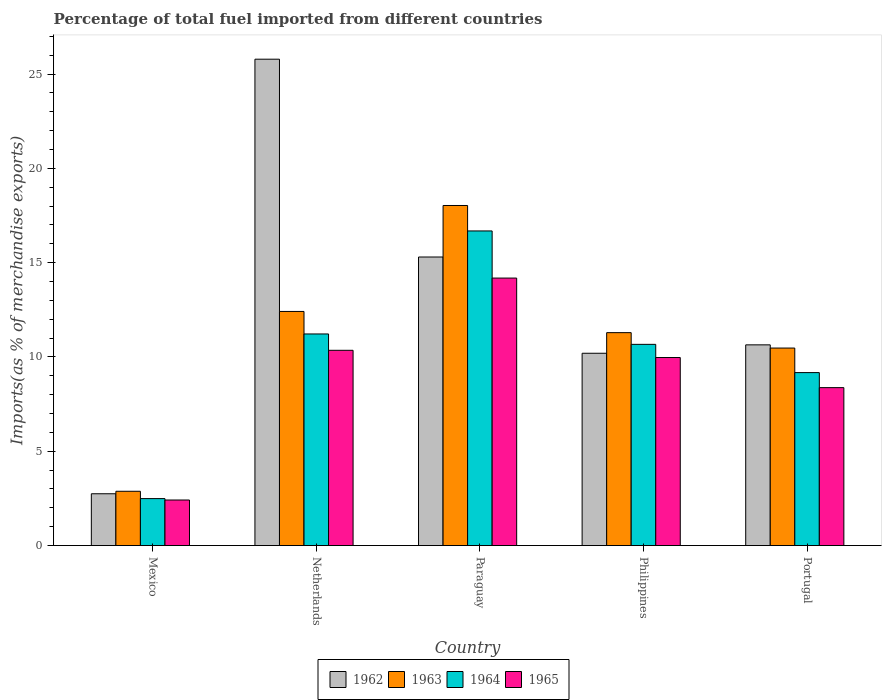Are the number of bars on each tick of the X-axis equal?
Your answer should be compact. Yes. How many bars are there on the 1st tick from the right?
Provide a short and direct response. 4. In how many cases, is the number of bars for a given country not equal to the number of legend labels?
Keep it short and to the point. 0. What is the percentage of imports to different countries in 1964 in Philippines?
Provide a short and direct response. 10.67. Across all countries, what is the maximum percentage of imports to different countries in 1962?
Your answer should be very brief. 25.79. Across all countries, what is the minimum percentage of imports to different countries in 1963?
Your answer should be compact. 2.88. In which country was the percentage of imports to different countries in 1963 maximum?
Your answer should be very brief. Paraguay. What is the total percentage of imports to different countries in 1962 in the graph?
Give a very brief answer. 64.67. What is the difference between the percentage of imports to different countries in 1962 in Netherlands and that in Philippines?
Give a very brief answer. 15.59. What is the difference between the percentage of imports to different countries in 1964 in Netherlands and the percentage of imports to different countries in 1965 in Mexico?
Offer a terse response. 8.8. What is the average percentage of imports to different countries in 1965 per country?
Your answer should be compact. 9.06. What is the difference between the percentage of imports to different countries of/in 1965 and percentage of imports to different countries of/in 1962 in Paraguay?
Give a very brief answer. -1.12. What is the ratio of the percentage of imports to different countries in 1963 in Mexico to that in Paraguay?
Your response must be concise. 0.16. Is the percentage of imports to different countries in 1965 in Philippines less than that in Portugal?
Provide a short and direct response. No. What is the difference between the highest and the second highest percentage of imports to different countries in 1965?
Provide a short and direct response. -0.38. What is the difference between the highest and the lowest percentage of imports to different countries in 1963?
Provide a short and direct response. 15.15. In how many countries, is the percentage of imports to different countries in 1963 greater than the average percentage of imports to different countries in 1963 taken over all countries?
Keep it short and to the point. 3. Is it the case that in every country, the sum of the percentage of imports to different countries in 1963 and percentage of imports to different countries in 1965 is greater than the sum of percentage of imports to different countries in 1962 and percentage of imports to different countries in 1964?
Your answer should be compact. No. What does the 3rd bar from the left in Netherlands represents?
Make the answer very short. 1964. What is the difference between two consecutive major ticks on the Y-axis?
Your answer should be compact. 5. Does the graph contain any zero values?
Provide a short and direct response. No. Does the graph contain grids?
Offer a terse response. No. How are the legend labels stacked?
Offer a very short reply. Horizontal. What is the title of the graph?
Your response must be concise. Percentage of total fuel imported from different countries. Does "2002" appear as one of the legend labels in the graph?
Offer a very short reply. No. What is the label or title of the X-axis?
Make the answer very short. Country. What is the label or title of the Y-axis?
Offer a very short reply. Imports(as % of merchandise exports). What is the Imports(as % of merchandise exports) of 1962 in Mexico?
Your answer should be compact. 2.75. What is the Imports(as % of merchandise exports) of 1963 in Mexico?
Offer a very short reply. 2.88. What is the Imports(as % of merchandise exports) of 1964 in Mexico?
Offer a terse response. 2.49. What is the Imports(as % of merchandise exports) of 1965 in Mexico?
Provide a short and direct response. 2.42. What is the Imports(as % of merchandise exports) of 1962 in Netherlands?
Give a very brief answer. 25.79. What is the Imports(as % of merchandise exports) of 1963 in Netherlands?
Ensure brevity in your answer.  12.41. What is the Imports(as % of merchandise exports) in 1964 in Netherlands?
Keep it short and to the point. 11.22. What is the Imports(as % of merchandise exports) in 1965 in Netherlands?
Keep it short and to the point. 10.35. What is the Imports(as % of merchandise exports) in 1962 in Paraguay?
Offer a very short reply. 15.3. What is the Imports(as % of merchandise exports) of 1963 in Paraguay?
Give a very brief answer. 18.03. What is the Imports(as % of merchandise exports) in 1964 in Paraguay?
Offer a very short reply. 16.68. What is the Imports(as % of merchandise exports) in 1965 in Paraguay?
Your answer should be very brief. 14.18. What is the Imports(as % of merchandise exports) in 1962 in Philippines?
Keep it short and to the point. 10.2. What is the Imports(as % of merchandise exports) in 1963 in Philippines?
Make the answer very short. 11.29. What is the Imports(as % of merchandise exports) in 1964 in Philippines?
Make the answer very short. 10.67. What is the Imports(as % of merchandise exports) in 1965 in Philippines?
Make the answer very short. 9.97. What is the Imports(as % of merchandise exports) of 1962 in Portugal?
Provide a short and direct response. 10.64. What is the Imports(as % of merchandise exports) in 1963 in Portugal?
Your answer should be compact. 10.47. What is the Imports(as % of merchandise exports) of 1964 in Portugal?
Give a very brief answer. 9.17. What is the Imports(as % of merchandise exports) in 1965 in Portugal?
Your answer should be compact. 8.37. Across all countries, what is the maximum Imports(as % of merchandise exports) of 1962?
Keep it short and to the point. 25.79. Across all countries, what is the maximum Imports(as % of merchandise exports) in 1963?
Offer a very short reply. 18.03. Across all countries, what is the maximum Imports(as % of merchandise exports) of 1964?
Keep it short and to the point. 16.68. Across all countries, what is the maximum Imports(as % of merchandise exports) in 1965?
Offer a very short reply. 14.18. Across all countries, what is the minimum Imports(as % of merchandise exports) of 1962?
Make the answer very short. 2.75. Across all countries, what is the minimum Imports(as % of merchandise exports) of 1963?
Offer a very short reply. 2.88. Across all countries, what is the minimum Imports(as % of merchandise exports) in 1964?
Your answer should be very brief. 2.49. Across all countries, what is the minimum Imports(as % of merchandise exports) in 1965?
Provide a short and direct response. 2.42. What is the total Imports(as % of merchandise exports) in 1962 in the graph?
Your answer should be very brief. 64.67. What is the total Imports(as % of merchandise exports) in 1963 in the graph?
Make the answer very short. 55.08. What is the total Imports(as % of merchandise exports) in 1964 in the graph?
Keep it short and to the point. 50.23. What is the total Imports(as % of merchandise exports) in 1965 in the graph?
Give a very brief answer. 45.29. What is the difference between the Imports(as % of merchandise exports) of 1962 in Mexico and that in Netherlands?
Ensure brevity in your answer.  -23.04. What is the difference between the Imports(as % of merchandise exports) in 1963 in Mexico and that in Netherlands?
Ensure brevity in your answer.  -9.53. What is the difference between the Imports(as % of merchandise exports) of 1964 in Mexico and that in Netherlands?
Ensure brevity in your answer.  -8.73. What is the difference between the Imports(as % of merchandise exports) of 1965 in Mexico and that in Netherlands?
Provide a short and direct response. -7.94. What is the difference between the Imports(as % of merchandise exports) of 1962 in Mexico and that in Paraguay?
Your response must be concise. -12.55. What is the difference between the Imports(as % of merchandise exports) in 1963 in Mexico and that in Paraguay?
Offer a very short reply. -15.15. What is the difference between the Imports(as % of merchandise exports) in 1964 in Mexico and that in Paraguay?
Your answer should be very brief. -14.19. What is the difference between the Imports(as % of merchandise exports) of 1965 in Mexico and that in Paraguay?
Your answer should be compact. -11.77. What is the difference between the Imports(as % of merchandise exports) in 1962 in Mexico and that in Philippines?
Your answer should be very brief. -7.45. What is the difference between the Imports(as % of merchandise exports) in 1963 in Mexico and that in Philippines?
Your answer should be very brief. -8.41. What is the difference between the Imports(as % of merchandise exports) of 1964 in Mexico and that in Philippines?
Your answer should be compact. -8.18. What is the difference between the Imports(as % of merchandise exports) in 1965 in Mexico and that in Philippines?
Keep it short and to the point. -7.55. What is the difference between the Imports(as % of merchandise exports) of 1962 in Mexico and that in Portugal?
Your answer should be compact. -7.89. What is the difference between the Imports(as % of merchandise exports) in 1963 in Mexico and that in Portugal?
Offer a terse response. -7.59. What is the difference between the Imports(as % of merchandise exports) of 1964 in Mexico and that in Portugal?
Keep it short and to the point. -6.68. What is the difference between the Imports(as % of merchandise exports) in 1965 in Mexico and that in Portugal?
Ensure brevity in your answer.  -5.96. What is the difference between the Imports(as % of merchandise exports) in 1962 in Netherlands and that in Paraguay?
Make the answer very short. 10.49. What is the difference between the Imports(as % of merchandise exports) of 1963 in Netherlands and that in Paraguay?
Your answer should be compact. -5.62. What is the difference between the Imports(as % of merchandise exports) of 1964 in Netherlands and that in Paraguay?
Make the answer very short. -5.46. What is the difference between the Imports(as % of merchandise exports) of 1965 in Netherlands and that in Paraguay?
Offer a terse response. -3.83. What is the difference between the Imports(as % of merchandise exports) of 1962 in Netherlands and that in Philippines?
Keep it short and to the point. 15.59. What is the difference between the Imports(as % of merchandise exports) in 1963 in Netherlands and that in Philippines?
Ensure brevity in your answer.  1.12. What is the difference between the Imports(as % of merchandise exports) of 1964 in Netherlands and that in Philippines?
Offer a terse response. 0.55. What is the difference between the Imports(as % of merchandise exports) in 1965 in Netherlands and that in Philippines?
Make the answer very short. 0.38. What is the difference between the Imports(as % of merchandise exports) of 1962 in Netherlands and that in Portugal?
Give a very brief answer. 15.15. What is the difference between the Imports(as % of merchandise exports) in 1963 in Netherlands and that in Portugal?
Provide a succinct answer. 1.94. What is the difference between the Imports(as % of merchandise exports) of 1964 in Netherlands and that in Portugal?
Make the answer very short. 2.05. What is the difference between the Imports(as % of merchandise exports) in 1965 in Netherlands and that in Portugal?
Keep it short and to the point. 1.98. What is the difference between the Imports(as % of merchandise exports) of 1962 in Paraguay and that in Philippines?
Offer a terse response. 5.1. What is the difference between the Imports(as % of merchandise exports) in 1963 in Paraguay and that in Philippines?
Keep it short and to the point. 6.74. What is the difference between the Imports(as % of merchandise exports) of 1964 in Paraguay and that in Philippines?
Your answer should be very brief. 6.01. What is the difference between the Imports(as % of merchandise exports) in 1965 in Paraguay and that in Philippines?
Your answer should be compact. 4.21. What is the difference between the Imports(as % of merchandise exports) in 1962 in Paraguay and that in Portugal?
Provide a short and direct response. 4.66. What is the difference between the Imports(as % of merchandise exports) in 1963 in Paraguay and that in Portugal?
Provide a succinct answer. 7.56. What is the difference between the Imports(as % of merchandise exports) in 1964 in Paraguay and that in Portugal?
Offer a very short reply. 7.51. What is the difference between the Imports(as % of merchandise exports) in 1965 in Paraguay and that in Portugal?
Your answer should be very brief. 5.81. What is the difference between the Imports(as % of merchandise exports) of 1962 in Philippines and that in Portugal?
Offer a very short reply. -0.45. What is the difference between the Imports(as % of merchandise exports) in 1963 in Philippines and that in Portugal?
Ensure brevity in your answer.  0.82. What is the difference between the Imports(as % of merchandise exports) in 1964 in Philippines and that in Portugal?
Keep it short and to the point. 1.5. What is the difference between the Imports(as % of merchandise exports) of 1965 in Philippines and that in Portugal?
Keep it short and to the point. 1.6. What is the difference between the Imports(as % of merchandise exports) of 1962 in Mexico and the Imports(as % of merchandise exports) of 1963 in Netherlands?
Ensure brevity in your answer.  -9.67. What is the difference between the Imports(as % of merchandise exports) in 1962 in Mexico and the Imports(as % of merchandise exports) in 1964 in Netherlands?
Offer a terse response. -8.47. What is the difference between the Imports(as % of merchandise exports) of 1962 in Mexico and the Imports(as % of merchandise exports) of 1965 in Netherlands?
Offer a terse response. -7.61. What is the difference between the Imports(as % of merchandise exports) in 1963 in Mexico and the Imports(as % of merchandise exports) in 1964 in Netherlands?
Give a very brief answer. -8.34. What is the difference between the Imports(as % of merchandise exports) of 1963 in Mexico and the Imports(as % of merchandise exports) of 1965 in Netherlands?
Keep it short and to the point. -7.47. What is the difference between the Imports(as % of merchandise exports) of 1964 in Mexico and the Imports(as % of merchandise exports) of 1965 in Netherlands?
Provide a short and direct response. -7.86. What is the difference between the Imports(as % of merchandise exports) in 1962 in Mexico and the Imports(as % of merchandise exports) in 1963 in Paraguay?
Keep it short and to the point. -15.28. What is the difference between the Imports(as % of merchandise exports) of 1962 in Mexico and the Imports(as % of merchandise exports) of 1964 in Paraguay?
Provide a short and direct response. -13.93. What is the difference between the Imports(as % of merchandise exports) of 1962 in Mexico and the Imports(as % of merchandise exports) of 1965 in Paraguay?
Your answer should be very brief. -11.44. What is the difference between the Imports(as % of merchandise exports) of 1963 in Mexico and the Imports(as % of merchandise exports) of 1964 in Paraguay?
Your response must be concise. -13.8. What is the difference between the Imports(as % of merchandise exports) in 1963 in Mexico and the Imports(as % of merchandise exports) in 1965 in Paraguay?
Keep it short and to the point. -11.3. What is the difference between the Imports(as % of merchandise exports) in 1964 in Mexico and the Imports(as % of merchandise exports) in 1965 in Paraguay?
Ensure brevity in your answer.  -11.69. What is the difference between the Imports(as % of merchandise exports) in 1962 in Mexico and the Imports(as % of merchandise exports) in 1963 in Philippines?
Provide a succinct answer. -8.54. What is the difference between the Imports(as % of merchandise exports) of 1962 in Mexico and the Imports(as % of merchandise exports) of 1964 in Philippines?
Offer a very short reply. -7.92. What is the difference between the Imports(as % of merchandise exports) of 1962 in Mexico and the Imports(as % of merchandise exports) of 1965 in Philippines?
Your answer should be compact. -7.22. What is the difference between the Imports(as % of merchandise exports) in 1963 in Mexico and the Imports(as % of merchandise exports) in 1964 in Philippines?
Offer a terse response. -7.79. What is the difference between the Imports(as % of merchandise exports) of 1963 in Mexico and the Imports(as % of merchandise exports) of 1965 in Philippines?
Your answer should be compact. -7.09. What is the difference between the Imports(as % of merchandise exports) in 1964 in Mexico and the Imports(as % of merchandise exports) in 1965 in Philippines?
Your response must be concise. -7.48. What is the difference between the Imports(as % of merchandise exports) in 1962 in Mexico and the Imports(as % of merchandise exports) in 1963 in Portugal?
Offer a very short reply. -7.73. What is the difference between the Imports(as % of merchandise exports) in 1962 in Mexico and the Imports(as % of merchandise exports) in 1964 in Portugal?
Keep it short and to the point. -6.42. What is the difference between the Imports(as % of merchandise exports) of 1962 in Mexico and the Imports(as % of merchandise exports) of 1965 in Portugal?
Offer a very short reply. -5.63. What is the difference between the Imports(as % of merchandise exports) of 1963 in Mexico and the Imports(as % of merchandise exports) of 1964 in Portugal?
Offer a terse response. -6.29. What is the difference between the Imports(as % of merchandise exports) of 1963 in Mexico and the Imports(as % of merchandise exports) of 1965 in Portugal?
Your response must be concise. -5.49. What is the difference between the Imports(as % of merchandise exports) in 1964 in Mexico and the Imports(as % of merchandise exports) in 1965 in Portugal?
Ensure brevity in your answer.  -5.88. What is the difference between the Imports(as % of merchandise exports) in 1962 in Netherlands and the Imports(as % of merchandise exports) in 1963 in Paraguay?
Your answer should be compact. 7.76. What is the difference between the Imports(as % of merchandise exports) of 1962 in Netherlands and the Imports(as % of merchandise exports) of 1964 in Paraguay?
Your response must be concise. 9.11. What is the difference between the Imports(as % of merchandise exports) in 1962 in Netherlands and the Imports(as % of merchandise exports) in 1965 in Paraguay?
Your answer should be very brief. 11.6. What is the difference between the Imports(as % of merchandise exports) in 1963 in Netherlands and the Imports(as % of merchandise exports) in 1964 in Paraguay?
Make the answer very short. -4.27. What is the difference between the Imports(as % of merchandise exports) of 1963 in Netherlands and the Imports(as % of merchandise exports) of 1965 in Paraguay?
Provide a short and direct response. -1.77. What is the difference between the Imports(as % of merchandise exports) of 1964 in Netherlands and the Imports(as % of merchandise exports) of 1965 in Paraguay?
Offer a terse response. -2.96. What is the difference between the Imports(as % of merchandise exports) in 1962 in Netherlands and the Imports(as % of merchandise exports) in 1963 in Philippines?
Offer a terse response. 14.5. What is the difference between the Imports(as % of merchandise exports) in 1962 in Netherlands and the Imports(as % of merchandise exports) in 1964 in Philippines?
Ensure brevity in your answer.  15.12. What is the difference between the Imports(as % of merchandise exports) of 1962 in Netherlands and the Imports(as % of merchandise exports) of 1965 in Philippines?
Offer a very short reply. 15.82. What is the difference between the Imports(as % of merchandise exports) of 1963 in Netherlands and the Imports(as % of merchandise exports) of 1964 in Philippines?
Provide a succinct answer. 1.74. What is the difference between the Imports(as % of merchandise exports) in 1963 in Netherlands and the Imports(as % of merchandise exports) in 1965 in Philippines?
Keep it short and to the point. 2.44. What is the difference between the Imports(as % of merchandise exports) of 1964 in Netherlands and the Imports(as % of merchandise exports) of 1965 in Philippines?
Make the answer very short. 1.25. What is the difference between the Imports(as % of merchandise exports) in 1962 in Netherlands and the Imports(as % of merchandise exports) in 1963 in Portugal?
Your answer should be compact. 15.32. What is the difference between the Imports(as % of merchandise exports) of 1962 in Netherlands and the Imports(as % of merchandise exports) of 1964 in Portugal?
Your answer should be compact. 16.62. What is the difference between the Imports(as % of merchandise exports) in 1962 in Netherlands and the Imports(as % of merchandise exports) in 1965 in Portugal?
Your response must be concise. 17.41. What is the difference between the Imports(as % of merchandise exports) of 1963 in Netherlands and the Imports(as % of merchandise exports) of 1964 in Portugal?
Provide a succinct answer. 3.24. What is the difference between the Imports(as % of merchandise exports) in 1963 in Netherlands and the Imports(as % of merchandise exports) in 1965 in Portugal?
Give a very brief answer. 4.04. What is the difference between the Imports(as % of merchandise exports) in 1964 in Netherlands and the Imports(as % of merchandise exports) in 1965 in Portugal?
Your answer should be compact. 2.85. What is the difference between the Imports(as % of merchandise exports) of 1962 in Paraguay and the Imports(as % of merchandise exports) of 1963 in Philippines?
Your answer should be very brief. 4.01. What is the difference between the Imports(as % of merchandise exports) of 1962 in Paraguay and the Imports(as % of merchandise exports) of 1964 in Philippines?
Keep it short and to the point. 4.63. What is the difference between the Imports(as % of merchandise exports) in 1962 in Paraguay and the Imports(as % of merchandise exports) in 1965 in Philippines?
Offer a very short reply. 5.33. What is the difference between the Imports(as % of merchandise exports) in 1963 in Paraguay and the Imports(as % of merchandise exports) in 1964 in Philippines?
Your answer should be very brief. 7.36. What is the difference between the Imports(as % of merchandise exports) of 1963 in Paraguay and the Imports(as % of merchandise exports) of 1965 in Philippines?
Provide a succinct answer. 8.06. What is the difference between the Imports(as % of merchandise exports) of 1964 in Paraguay and the Imports(as % of merchandise exports) of 1965 in Philippines?
Offer a terse response. 6.71. What is the difference between the Imports(as % of merchandise exports) of 1962 in Paraguay and the Imports(as % of merchandise exports) of 1963 in Portugal?
Offer a very short reply. 4.83. What is the difference between the Imports(as % of merchandise exports) in 1962 in Paraguay and the Imports(as % of merchandise exports) in 1964 in Portugal?
Ensure brevity in your answer.  6.13. What is the difference between the Imports(as % of merchandise exports) in 1962 in Paraguay and the Imports(as % of merchandise exports) in 1965 in Portugal?
Your answer should be compact. 6.93. What is the difference between the Imports(as % of merchandise exports) in 1963 in Paraguay and the Imports(as % of merchandise exports) in 1964 in Portugal?
Offer a very short reply. 8.86. What is the difference between the Imports(as % of merchandise exports) of 1963 in Paraguay and the Imports(as % of merchandise exports) of 1965 in Portugal?
Provide a short and direct response. 9.66. What is the difference between the Imports(as % of merchandise exports) in 1964 in Paraguay and the Imports(as % of merchandise exports) in 1965 in Portugal?
Provide a short and direct response. 8.31. What is the difference between the Imports(as % of merchandise exports) of 1962 in Philippines and the Imports(as % of merchandise exports) of 1963 in Portugal?
Offer a very short reply. -0.28. What is the difference between the Imports(as % of merchandise exports) in 1962 in Philippines and the Imports(as % of merchandise exports) in 1964 in Portugal?
Your answer should be compact. 1.03. What is the difference between the Imports(as % of merchandise exports) of 1962 in Philippines and the Imports(as % of merchandise exports) of 1965 in Portugal?
Your answer should be compact. 1.82. What is the difference between the Imports(as % of merchandise exports) in 1963 in Philippines and the Imports(as % of merchandise exports) in 1964 in Portugal?
Ensure brevity in your answer.  2.12. What is the difference between the Imports(as % of merchandise exports) in 1963 in Philippines and the Imports(as % of merchandise exports) in 1965 in Portugal?
Make the answer very short. 2.92. What is the difference between the Imports(as % of merchandise exports) of 1964 in Philippines and the Imports(as % of merchandise exports) of 1965 in Portugal?
Your response must be concise. 2.3. What is the average Imports(as % of merchandise exports) of 1962 per country?
Ensure brevity in your answer.  12.93. What is the average Imports(as % of merchandise exports) in 1963 per country?
Your response must be concise. 11.02. What is the average Imports(as % of merchandise exports) of 1964 per country?
Provide a short and direct response. 10.05. What is the average Imports(as % of merchandise exports) in 1965 per country?
Your response must be concise. 9.06. What is the difference between the Imports(as % of merchandise exports) of 1962 and Imports(as % of merchandise exports) of 1963 in Mexico?
Your response must be concise. -0.13. What is the difference between the Imports(as % of merchandise exports) in 1962 and Imports(as % of merchandise exports) in 1964 in Mexico?
Your answer should be compact. 0.26. What is the difference between the Imports(as % of merchandise exports) of 1962 and Imports(as % of merchandise exports) of 1965 in Mexico?
Keep it short and to the point. 0.33. What is the difference between the Imports(as % of merchandise exports) of 1963 and Imports(as % of merchandise exports) of 1964 in Mexico?
Your answer should be very brief. 0.39. What is the difference between the Imports(as % of merchandise exports) in 1963 and Imports(as % of merchandise exports) in 1965 in Mexico?
Make the answer very short. 0.46. What is the difference between the Imports(as % of merchandise exports) of 1964 and Imports(as % of merchandise exports) of 1965 in Mexico?
Ensure brevity in your answer.  0.07. What is the difference between the Imports(as % of merchandise exports) of 1962 and Imports(as % of merchandise exports) of 1963 in Netherlands?
Keep it short and to the point. 13.37. What is the difference between the Imports(as % of merchandise exports) of 1962 and Imports(as % of merchandise exports) of 1964 in Netherlands?
Give a very brief answer. 14.57. What is the difference between the Imports(as % of merchandise exports) in 1962 and Imports(as % of merchandise exports) in 1965 in Netherlands?
Offer a terse response. 15.43. What is the difference between the Imports(as % of merchandise exports) in 1963 and Imports(as % of merchandise exports) in 1964 in Netherlands?
Offer a very short reply. 1.19. What is the difference between the Imports(as % of merchandise exports) of 1963 and Imports(as % of merchandise exports) of 1965 in Netherlands?
Provide a short and direct response. 2.06. What is the difference between the Imports(as % of merchandise exports) of 1964 and Imports(as % of merchandise exports) of 1965 in Netherlands?
Keep it short and to the point. 0.87. What is the difference between the Imports(as % of merchandise exports) of 1962 and Imports(as % of merchandise exports) of 1963 in Paraguay?
Your answer should be very brief. -2.73. What is the difference between the Imports(as % of merchandise exports) of 1962 and Imports(as % of merchandise exports) of 1964 in Paraguay?
Your answer should be compact. -1.38. What is the difference between the Imports(as % of merchandise exports) of 1962 and Imports(as % of merchandise exports) of 1965 in Paraguay?
Provide a short and direct response. 1.12. What is the difference between the Imports(as % of merchandise exports) in 1963 and Imports(as % of merchandise exports) in 1964 in Paraguay?
Offer a terse response. 1.35. What is the difference between the Imports(as % of merchandise exports) of 1963 and Imports(as % of merchandise exports) of 1965 in Paraguay?
Your response must be concise. 3.85. What is the difference between the Imports(as % of merchandise exports) in 1964 and Imports(as % of merchandise exports) in 1965 in Paraguay?
Make the answer very short. 2.5. What is the difference between the Imports(as % of merchandise exports) of 1962 and Imports(as % of merchandise exports) of 1963 in Philippines?
Your answer should be very brief. -1.09. What is the difference between the Imports(as % of merchandise exports) of 1962 and Imports(as % of merchandise exports) of 1964 in Philippines?
Ensure brevity in your answer.  -0.47. What is the difference between the Imports(as % of merchandise exports) of 1962 and Imports(as % of merchandise exports) of 1965 in Philippines?
Provide a short and direct response. 0.23. What is the difference between the Imports(as % of merchandise exports) of 1963 and Imports(as % of merchandise exports) of 1964 in Philippines?
Offer a very short reply. 0.62. What is the difference between the Imports(as % of merchandise exports) of 1963 and Imports(as % of merchandise exports) of 1965 in Philippines?
Ensure brevity in your answer.  1.32. What is the difference between the Imports(as % of merchandise exports) of 1964 and Imports(as % of merchandise exports) of 1965 in Philippines?
Give a very brief answer. 0.7. What is the difference between the Imports(as % of merchandise exports) of 1962 and Imports(as % of merchandise exports) of 1963 in Portugal?
Provide a short and direct response. 0.17. What is the difference between the Imports(as % of merchandise exports) in 1962 and Imports(as % of merchandise exports) in 1964 in Portugal?
Provide a succinct answer. 1.47. What is the difference between the Imports(as % of merchandise exports) of 1962 and Imports(as % of merchandise exports) of 1965 in Portugal?
Keep it short and to the point. 2.27. What is the difference between the Imports(as % of merchandise exports) in 1963 and Imports(as % of merchandise exports) in 1964 in Portugal?
Make the answer very short. 1.3. What is the difference between the Imports(as % of merchandise exports) in 1963 and Imports(as % of merchandise exports) in 1965 in Portugal?
Offer a very short reply. 2.1. What is the difference between the Imports(as % of merchandise exports) in 1964 and Imports(as % of merchandise exports) in 1965 in Portugal?
Give a very brief answer. 0.8. What is the ratio of the Imports(as % of merchandise exports) in 1962 in Mexico to that in Netherlands?
Your answer should be very brief. 0.11. What is the ratio of the Imports(as % of merchandise exports) of 1963 in Mexico to that in Netherlands?
Your response must be concise. 0.23. What is the ratio of the Imports(as % of merchandise exports) in 1964 in Mexico to that in Netherlands?
Make the answer very short. 0.22. What is the ratio of the Imports(as % of merchandise exports) in 1965 in Mexico to that in Netherlands?
Keep it short and to the point. 0.23. What is the ratio of the Imports(as % of merchandise exports) of 1962 in Mexico to that in Paraguay?
Provide a succinct answer. 0.18. What is the ratio of the Imports(as % of merchandise exports) of 1963 in Mexico to that in Paraguay?
Your answer should be very brief. 0.16. What is the ratio of the Imports(as % of merchandise exports) of 1964 in Mexico to that in Paraguay?
Give a very brief answer. 0.15. What is the ratio of the Imports(as % of merchandise exports) of 1965 in Mexico to that in Paraguay?
Your answer should be compact. 0.17. What is the ratio of the Imports(as % of merchandise exports) in 1962 in Mexico to that in Philippines?
Make the answer very short. 0.27. What is the ratio of the Imports(as % of merchandise exports) in 1963 in Mexico to that in Philippines?
Your response must be concise. 0.26. What is the ratio of the Imports(as % of merchandise exports) of 1964 in Mexico to that in Philippines?
Keep it short and to the point. 0.23. What is the ratio of the Imports(as % of merchandise exports) of 1965 in Mexico to that in Philippines?
Give a very brief answer. 0.24. What is the ratio of the Imports(as % of merchandise exports) in 1962 in Mexico to that in Portugal?
Your response must be concise. 0.26. What is the ratio of the Imports(as % of merchandise exports) of 1963 in Mexico to that in Portugal?
Your response must be concise. 0.27. What is the ratio of the Imports(as % of merchandise exports) of 1964 in Mexico to that in Portugal?
Offer a terse response. 0.27. What is the ratio of the Imports(as % of merchandise exports) in 1965 in Mexico to that in Portugal?
Offer a terse response. 0.29. What is the ratio of the Imports(as % of merchandise exports) of 1962 in Netherlands to that in Paraguay?
Give a very brief answer. 1.69. What is the ratio of the Imports(as % of merchandise exports) of 1963 in Netherlands to that in Paraguay?
Your answer should be compact. 0.69. What is the ratio of the Imports(as % of merchandise exports) of 1964 in Netherlands to that in Paraguay?
Your answer should be very brief. 0.67. What is the ratio of the Imports(as % of merchandise exports) of 1965 in Netherlands to that in Paraguay?
Your answer should be compact. 0.73. What is the ratio of the Imports(as % of merchandise exports) in 1962 in Netherlands to that in Philippines?
Make the answer very short. 2.53. What is the ratio of the Imports(as % of merchandise exports) of 1963 in Netherlands to that in Philippines?
Offer a very short reply. 1.1. What is the ratio of the Imports(as % of merchandise exports) of 1964 in Netherlands to that in Philippines?
Keep it short and to the point. 1.05. What is the ratio of the Imports(as % of merchandise exports) in 1965 in Netherlands to that in Philippines?
Offer a very short reply. 1.04. What is the ratio of the Imports(as % of merchandise exports) of 1962 in Netherlands to that in Portugal?
Provide a short and direct response. 2.42. What is the ratio of the Imports(as % of merchandise exports) of 1963 in Netherlands to that in Portugal?
Offer a very short reply. 1.19. What is the ratio of the Imports(as % of merchandise exports) of 1964 in Netherlands to that in Portugal?
Offer a terse response. 1.22. What is the ratio of the Imports(as % of merchandise exports) in 1965 in Netherlands to that in Portugal?
Ensure brevity in your answer.  1.24. What is the ratio of the Imports(as % of merchandise exports) of 1962 in Paraguay to that in Philippines?
Your answer should be compact. 1.5. What is the ratio of the Imports(as % of merchandise exports) in 1963 in Paraguay to that in Philippines?
Offer a very short reply. 1.6. What is the ratio of the Imports(as % of merchandise exports) of 1964 in Paraguay to that in Philippines?
Provide a succinct answer. 1.56. What is the ratio of the Imports(as % of merchandise exports) of 1965 in Paraguay to that in Philippines?
Your answer should be compact. 1.42. What is the ratio of the Imports(as % of merchandise exports) of 1962 in Paraguay to that in Portugal?
Offer a terse response. 1.44. What is the ratio of the Imports(as % of merchandise exports) of 1963 in Paraguay to that in Portugal?
Give a very brief answer. 1.72. What is the ratio of the Imports(as % of merchandise exports) in 1964 in Paraguay to that in Portugal?
Your answer should be very brief. 1.82. What is the ratio of the Imports(as % of merchandise exports) of 1965 in Paraguay to that in Portugal?
Your answer should be compact. 1.69. What is the ratio of the Imports(as % of merchandise exports) in 1962 in Philippines to that in Portugal?
Offer a terse response. 0.96. What is the ratio of the Imports(as % of merchandise exports) of 1963 in Philippines to that in Portugal?
Offer a very short reply. 1.08. What is the ratio of the Imports(as % of merchandise exports) in 1964 in Philippines to that in Portugal?
Your response must be concise. 1.16. What is the ratio of the Imports(as % of merchandise exports) of 1965 in Philippines to that in Portugal?
Offer a very short reply. 1.19. What is the difference between the highest and the second highest Imports(as % of merchandise exports) of 1962?
Your answer should be compact. 10.49. What is the difference between the highest and the second highest Imports(as % of merchandise exports) in 1963?
Provide a short and direct response. 5.62. What is the difference between the highest and the second highest Imports(as % of merchandise exports) in 1964?
Your answer should be compact. 5.46. What is the difference between the highest and the second highest Imports(as % of merchandise exports) in 1965?
Offer a terse response. 3.83. What is the difference between the highest and the lowest Imports(as % of merchandise exports) of 1962?
Keep it short and to the point. 23.04. What is the difference between the highest and the lowest Imports(as % of merchandise exports) of 1963?
Give a very brief answer. 15.15. What is the difference between the highest and the lowest Imports(as % of merchandise exports) of 1964?
Your answer should be very brief. 14.19. What is the difference between the highest and the lowest Imports(as % of merchandise exports) of 1965?
Give a very brief answer. 11.77. 